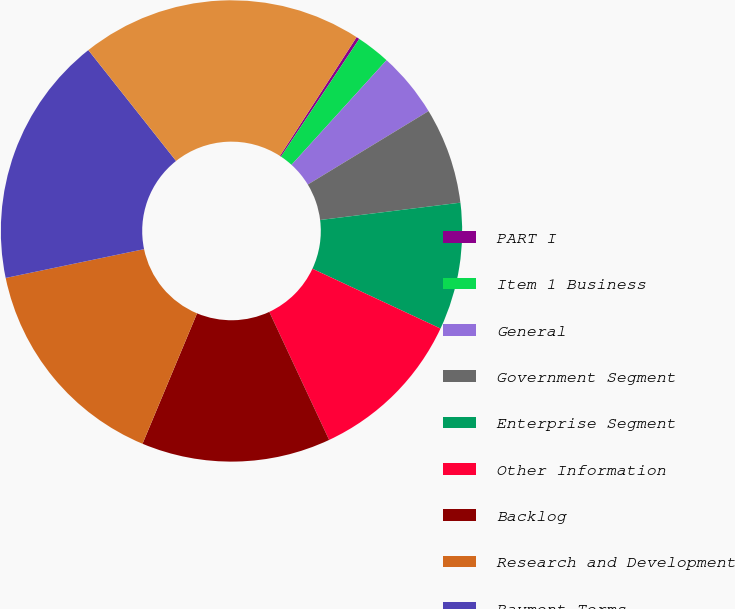<chart> <loc_0><loc_0><loc_500><loc_500><pie_chart><fcel>PART I<fcel>Item 1 Business<fcel>General<fcel>Government Segment<fcel>Enterprise Segment<fcel>Other Information<fcel>Backlog<fcel>Research and Development<fcel>Payment Terms<fcel>Regulatory Matters<nl><fcel>0.22%<fcel>2.39%<fcel>4.57%<fcel>6.74%<fcel>8.91%<fcel>11.09%<fcel>13.26%<fcel>15.43%<fcel>17.61%<fcel>19.78%<nl></chart> 